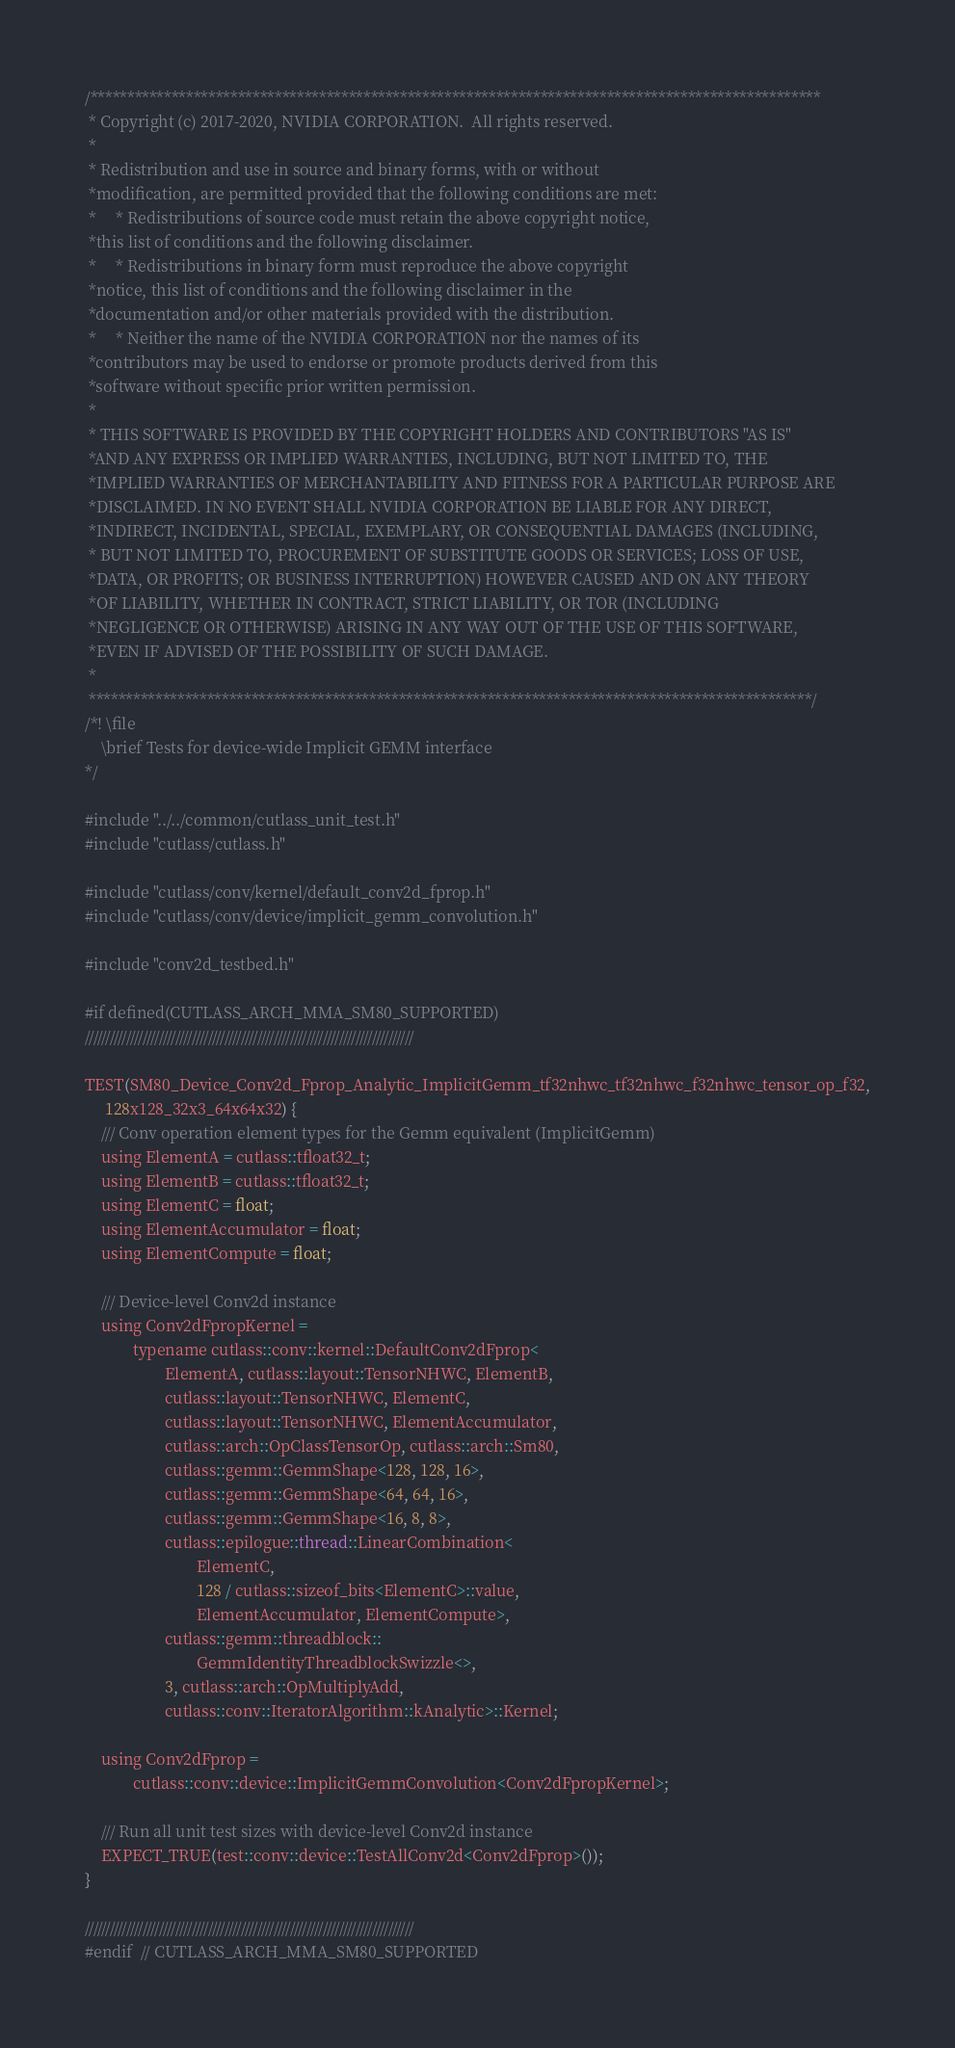Convert code to text. <code><loc_0><loc_0><loc_500><loc_500><_Cuda_>/***************************************************************************************************
 * Copyright (c) 2017-2020, NVIDIA CORPORATION.  All rights reserved.
 *
 * Redistribution and use in source and binary forms, with or without
 *modification, are permitted provided that the following conditions are met:
 *     * Redistributions of source code must retain the above copyright notice,
 *this list of conditions and the following disclaimer.
 *     * Redistributions in binary form must reproduce the above copyright
 *notice, this list of conditions and the following disclaimer in the
 *documentation and/or other materials provided with the distribution.
 *     * Neither the name of the NVIDIA CORPORATION nor the names of its
 *contributors may be used to endorse or promote products derived from this
 *software without specific prior written permission.
 *
 * THIS SOFTWARE IS PROVIDED BY THE COPYRIGHT HOLDERS AND CONTRIBUTORS "AS IS"
 *AND ANY EXPRESS OR IMPLIED WARRANTIES, INCLUDING, BUT NOT LIMITED TO, THE
 *IMPLIED WARRANTIES OF MERCHANTABILITY AND FITNESS FOR A PARTICULAR PURPOSE ARE
 *DISCLAIMED. IN NO EVENT SHALL NVIDIA CORPORATION BE LIABLE FOR ANY DIRECT,
 *INDIRECT, INCIDENTAL, SPECIAL, EXEMPLARY, OR CONSEQUENTIAL DAMAGES (INCLUDING,
 * BUT NOT LIMITED TO, PROCUREMENT OF SUBSTITUTE GOODS OR SERVICES; LOSS OF USE,
 *DATA, OR PROFITS; OR BUSINESS INTERRUPTION) HOWEVER CAUSED AND ON ANY THEORY
 *OF LIABILITY, WHETHER IN CONTRACT, STRICT LIABILITY, OR TOR (INCLUDING
 *NEGLIGENCE OR OTHERWISE) ARISING IN ANY WAY OUT OF THE USE OF THIS SOFTWARE,
 *EVEN IF ADVISED OF THE POSSIBILITY OF SUCH DAMAGE.
 *
 **************************************************************************************************/
/*! \file
    \brief Tests for device-wide Implicit GEMM interface
*/

#include "../../common/cutlass_unit_test.h"
#include "cutlass/cutlass.h"

#include "cutlass/conv/kernel/default_conv2d_fprop.h"
#include "cutlass/conv/device/implicit_gemm_convolution.h"

#include "conv2d_testbed.h"

#if defined(CUTLASS_ARCH_MMA_SM80_SUPPORTED)
////////////////////////////////////////////////////////////////////////////////

TEST(SM80_Device_Conv2d_Fprop_Analytic_ImplicitGemm_tf32nhwc_tf32nhwc_f32nhwc_tensor_op_f32,
     128x128_32x3_64x64x32) {
    /// Conv operation element types for the Gemm equivalent (ImplicitGemm)
    using ElementA = cutlass::tfloat32_t;
    using ElementB = cutlass::tfloat32_t;
    using ElementC = float;
    using ElementAccumulator = float;
    using ElementCompute = float;

    /// Device-level Conv2d instance
    using Conv2dFpropKernel =
            typename cutlass::conv::kernel::DefaultConv2dFprop<
                    ElementA, cutlass::layout::TensorNHWC, ElementB,
                    cutlass::layout::TensorNHWC, ElementC,
                    cutlass::layout::TensorNHWC, ElementAccumulator,
                    cutlass::arch::OpClassTensorOp, cutlass::arch::Sm80,
                    cutlass::gemm::GemmShape<128, 128, 16>,
                    cutlass::gemm::GemmShape<64, 64, 16>,
                    cutlass::gemm::GemmShape<16, 8, 8>,
                    cutlass::epilogue::thread::LinearCombination<
                            ElementC,
                            128 / cutlass::sizeof_bits<ElementC>::value,
                            ElementAccumulator, ElementCompute>,
                    cutlass::gemm::threadblock::
                            GemmIdentityThreadblockSwizzle<>,
                    3, cutlass::arch::OpMultiplyAdd,
                    cutlass::conv::IteratorAlgorithm::kAnalytic>::Kernel;

    using Conv2dFprop =
            cutlass::conv::device::ImplicitGemmConvolution<Conv2dFpropKernel>;

    /// Run all unit test sizes with device-level Conv2d instance
    EXPECT_TRUE(test::conv::device::TestAllConv2d<Conv2dFprop>());
}

////////////////////////////////////////////////////////////////////////////////
#endif  // CUTLASS_ARCH_MMA_SM80_SUPPORTED
</code> 